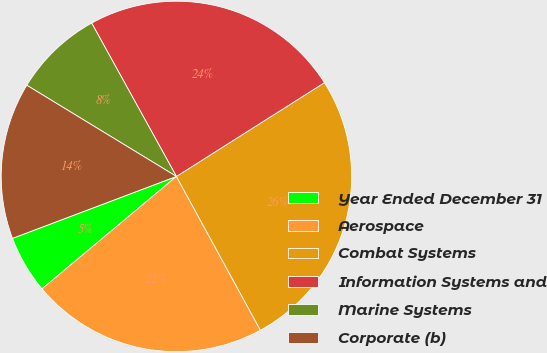Convert chart to OTSL. <chart><loc_0><loc_0><loc_500><loc_500><pie_chart><fcel>Year Ended December 31<fcel>Aerospace<fcel>Combat Systems<fcel>Information Systems and<fcel>Marine Systems<fcel>Corporate (b)<nl><fcel>5.34%<fcel>21.87%<fcel>26.03%<fcel>24.05%<fcel>8.25%<fcel>14.46%<nl></chart> 